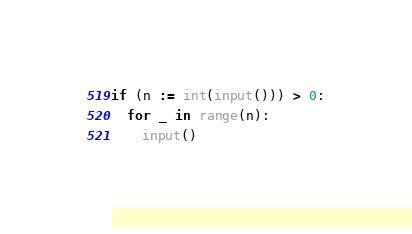Convert code to text. <code><loc_0><loc_0><loc_500><loc_500><_Python_>if (n := int(input())) > 0:
  for _ in range(n):
    input()</code> 